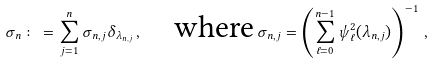Convert formula to latex. <formula><loc_0><loc_0><loc_500><loc_500>\sigma _ { n } \colon = \sum _ { j = 1 } ^ { n } \sigma _ { n , j } \delta _ { \lambda _ { n , j } } \, , \quad \text {where} \, \sigma _ { n , j } = \left ( \sum _ { \ell = 0 } ^ { n - 1 } \psi _ { \ell } ^ { 2 } ( \lambda _ { n , j } ) \right ) ^ { - 1 } \, ,</formula> 